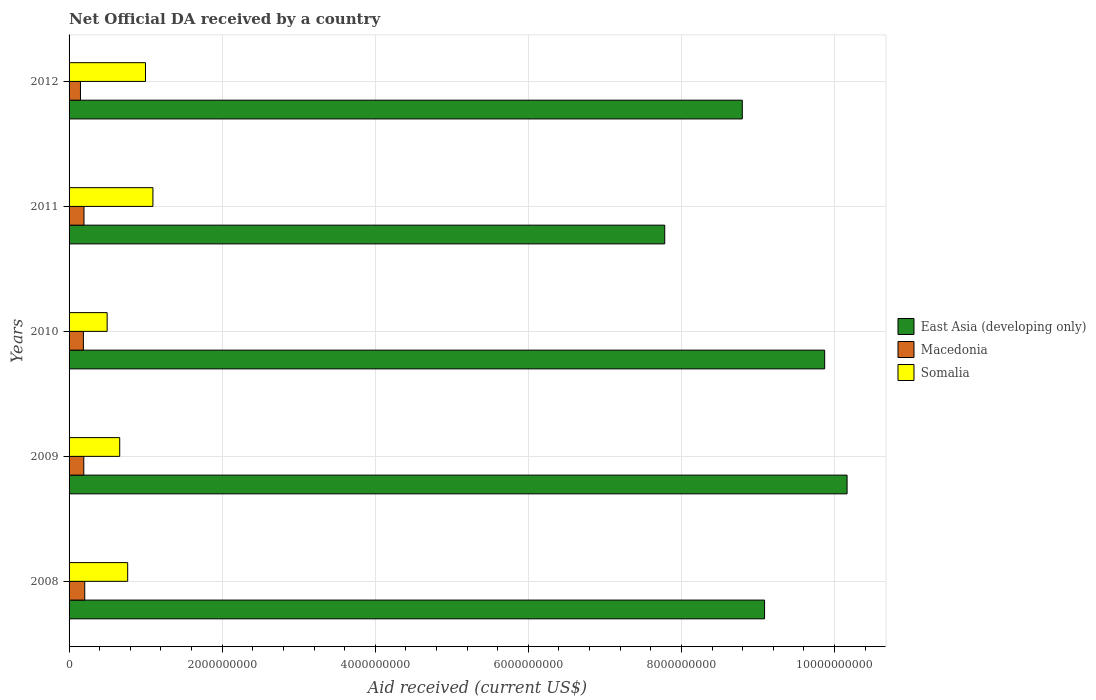How many different coloured bars are there?
Offer a very short reply. 3. Are the number of bars per tick equal to the number of legend labels?
Your answer should be very brief. Yes. How many bars are there on the 3rd tick from the bottom?
Your answer should be compact. 3. What is the label of the 2nd group of bars from the top?
Provide a succinct answer. 2011. In how many cases, is the number of bars for a given year not equal to the number of legend labels?
Provide a short and direct response. 0. What is the net official development assistance aid received in Somalia in 2011?
Your answer should be compact. 1.10e+09. Across all years, what is the maximum net official development assistance aid received in Somalia?
Provide a short and direct response. 1.10e+09. Across all years, what is the minimum net official development assistance aid received in Macedonia?
Give a very brief answer. 1.49e+08. What is the total net official development assistance aid received in Somalia in the graph?
Provide a succinct answer. 4.02e+09. What is the difference between the net official development assistance aid received in East Asia (developing only) in 2009 and that in 2010?
Your answer should be very brief. 2.93e+08. What is the difference between the net official development assistance aid received in Somalia in 2010 and the net official development assistance aid received in East Asia (developing only) in 2011?
Provide a short and direct response. -7.28e+09. What is the average net official development assistance aid received in Macedonia per year?
Make the answer very short. 1.86e+08. In the year 2009, what is the difference between the net official development assistance aid received in Macedonia and net official development assistance aid received in East Asia (developing only)?
Give a very brief answer. -9.97e+09. What is the ratio of the net official development assistance aid received in Somalia in 2008 to that in 2010?
Your answer should be compact. 1.54. Is the net official development assistance aid received in Macedonia in 2011 less than that in 2012?
Your response must be concise. No. What is the difference between the highest and the second highest net official development assistance aid received in Macedonia?
Provide a short and direct response. 9.74e+06. What is the difference between the highest and the lowest net official development assistance aid received in Somalia?
Make the answer very short. 5.98e+08. In how many years, is the net official development assistance aid received in East Asia (developing only) greater than the average net official development assistance aid received in East Asia (developing only) taken over all years?
Offer a very short reply. 2. What does the 2nd bar from the top in 2008 represents?
Offer a very short reply. Macedonia. What does the 1st bar from the bottom in 2009 represents?
Your response must be concise. East Asia (developing only). Is it the case that in every year, the sum of the net official development assistance aid received in Somalia and net official development assistance aid received in Macedonia is greater than the net official development assistance aid received in East Asia (developing only)?
Offer a very short reply. No. How many bars are there?
Keep it short and to the point. 15. Are the values on the major ticks of X-axis written in scientific E-notation?
Provide a succinct answer. No. How many legend labels are there?
Offer a terse response. 3. How are the legend labels stacked?
Keep it short and to the point. Vertical. What is the title of the graph?
Keep it short and to the point. Net Official DA received by a country. Does "Belarus" appear as one of the legend labels in the graph?
Your answer should be very brief. No. What is the label or title of the X-axis?
Keep it short and to the point. Aid received (current US$). What is the Aid received (current US$) in East Asia (developing only) in 2008?
Your answer should be compact. 9.09e+09. What is the Aid received (current US$) in Macedonia in 2008?
Offer a terse response. 2.05e+08. What is the Aid received (current US$) of Somalia in 2008?
Provide a short and direct response. 7.66e+08. What is the Aid received (current US$) of East Asia (developing only) in 2009?
Offer a terse response. 1.02e+1. What is the Aid received (current US$) of Macedonia in 2009?
Offer a very short reply. 1.92e+08. What is the Aid received (current US$) in Somalia in 2009?
Keep it short and to the point. 6.62e+08. What is the Aid received (current US$) in East Asia (developing only) in 2010?
Offer a very short reply. 9.87e+09. What is the Aid received (current US$) of Macedonia in 2010?
Keep it short and to the point. 1.87e+08. What is the Aid received (current US$) in Somalia in 2010?
Give a very brief answer. 4.98e+08. What is the Aid received (current US$) of East Asia (developing only) in 2011?
Offer a terse response. 7.78e+09. What is the Aid received (current US$) of Macedonia in 2011?
Provide a short and direct response. 1.95e+08. What is the Aid received (current US$) of Somalia in 2011?
Provide a succinct answer. 1.10e+09. What is the Aid received (current US$) of East Asia (developing only) in 2012?
Offer a terse response. 8.80e+09. What is the Aid received (current US$) of Macedonia in 2012?
Offer a very short reply. 1.49e+08. What is the Aid received (current US$) in Somalia in 2012?
Provide a short and direct response. 9.99e+08. Across all years, what is the maximum Aid received (current US$) of East Asia (developing only)?
Give a very brief answer. 1.02e+1. Across all years, what is the maximum Aid received (current US$) in Macedonia?
Ensure brevity in your answer.  2.05e+08. Across all years, what is the maximum Aid received (current US$) of Somalia?
Provide a succinct answer. 1.10e+09. Across all years, what is the minimum Aid received (current US$) of East Asia (developing only)?
Provide a short and direct response. 7.78e+09. Across all years, what is the minimum Aid received (current US$) of Macedonia?
Ensure brevity in your answer.  1.49e+08. Across all years, what is the minimum Aid received (current US$) in Somalia?
Ensure brevity in your answer.  4.98e+08. What is the total Aid received (current US$) in East Asia (developing only) in the graph?
Your response must be concise. 4.57e+1. What is the total Aid received (current US$) of Macedonia in the graph?
Give a very brief answer. 9.28e+08. What is the total Aid received (current US$) of Somalia in the graph?
Offer a very short reply. 4.02e+09. What is the difference between the Aid received (current US$) of East Asia (developing only) in 2008 and that in 2009?
Provide a succinct answer. -1.08e+09. What is the difference between the Aid received (current US$) in Macedonia in 2008 and that in 2009?
Ensure brevity in your answer.  1.22e+07. What is the difference between the Aid received (current US$) in Somalia in 2008 and that in 2009?
Provide a short and direct response. 1.04e+08. What is the difference between the Aid received (current US$) of East Asia (developing only) in 2008 and that in 2010?
Your answer should be compact. -7.85e+08. What is the difference between the Aid received (current US$) of Macedonia in 2008 and that in 2010?
Your response must be concise. 1.75e+07. What is the difference between the Aid received (current US$) in Somalia in 2008 and that in 2010?
Your response must be concise. 2.68e+08. What is the difference between the Aid received (current US$) in East Asia (developing only) in 2008 and that in 2011?
Keep it short and to the point. 1.30e+09. What is the difference between the Aid received (current US$) in Macedonia in 2008 and that in 2011?
Your response must be concise. 9.74e+06. What is the difference between the Aid received (current US$) of Somalia in 2008 and that in 2011?
Make the answer very short. -3.30e+08. What is the difference between the Aid received (current US$) of East Asia (developing only) in 2008 and that in 2012?
Keep it short and to the point. 2.91e+08. What is the difference between the Aid received (current US$) in Macedonia in 2008 and that in 2012?
Provide a short and direct response. 5.58e+07. What is the difference between the Aid received (current US$) in Somalia in 2008 and that in 2012?
Provide a short and direct response. -2.33e+08. What is the difference between the Aid received (current US$) in East Asia (developing only) in 2009 and that in 2010?
Provide a short and direct response. 2.93e+08. What is the difference between the Aid received (current US$) of Macedonia in 2009 and that in 2010?
Offer a very short reply. 5.30e+06. What is the difference between the Aid received (current US$) of Somalia in 2009 and that in 2010?
Your answer should be compact. 1.64e+08. What is the difference between the Aid received (current US$) of East Asia (developing only) in 2009 and that in 2011?
Ensure brevity in your answer.  2.38e+09. What is the difference between the Aid received (current US$) in Macedonia in 2009 and that in 2011?
Give a very brief answer. -2.50e+06. What is the difference between the Aid received (current US$) in Somalia in 2009 and that in 2011?
Your answer should be very brief. -4.34e+08. What is the difference between the Aid received (current US$) of East Asia (developing only) in 2009 and that in 2012?
Provide a succinct answer. 1.37e+09. What is the difference between the Aid received (current US$) of Macedonia in 2009 and that in 2012?
Make the answer very short. 4.35e+07. What is the difference between the Aid received (current US$) in Somalia in 2009 and that in 2012?
Ensure brevity in your answer.  -3.37e+08. What is the difference between the Aid received (current US$) in East Asia (developing only) in 2010 and that in 2011?
Offer a very short reply. 2.09e+09. What is the difference between the Aid received (current US$) of Macedonia in 2010 and that in 2011?
Provide a short and direct response. -7.80e+06. What is the difference between the Aid received (current US$) of Somalia in 2010 and that in 2011?
Offer a terse response. -5.98e+08. What is the difference between the Aid received (current US$) of East Asia (developing only) in 2010 and that in 2012?
Keep it short and to the point. 1.08e+09. What is the difference between the Aid received (current US$) in Macedonia in 2010 and that in 2012?
Your answer should be compact. 3.82e+07. What is the difference between the Aid received (current US$) in Somalia in 2010 and that in 2012?
Your answer should be very brief. -5.01e+08. What is the difference between the Aid received (current US$) in East Asia (developing only) in 2011 and that in 2012?
Your answer should be very brief. -1.01e+09. What is the difference between the Aid received (current US$) of Macedonia in 2011 and that in 2012?
Provide a succinct answer. 4.60e+07. What is the difference between the Aid received (current US$) of Somalia in 2011 and that in 2012?
Provide a short and direct response. 9.70e+07. What is the difference between the Aid received (current US$) of East Asia (developing only) in 2008 and the Aid received (current US$) of Macedonia in 2009?
Give a very brief answer. 8.89e+09. What is the difference between the Aid received (current US$) in East Asia (developing only) in 2008 and the Aid received (current US$) in Somalia in 2009?
Your response must be concise. 8.43e+09. What is the difference between the Aid received (current US$) in Macedonia in 2008 and the Aid received (current US$) in Somalia in 2009?
Give a very brief answer. -4.57e+08. What is the difference between the Aid received (current US$) in East Asia (developing only) in 2008 and the Aid received (current US$) in Macedonia in 2010?
Your answer should be compact. 8.90e+09. What is the difference between the Aid received (current US$) of East Asia (developing only) in 2008 and the Aid received (current US$) of Somalia in 2010?
Make the answer very short. 8.59e+09. What is the difference between the Aid received (current US$) in Macedonia in 2008 and the Aid received (current US$) in Somalia in 2010?
Your answer should be compact. -2.93e+08. What is the difference between the Aid received (current US$) of East Asia (developing only) in 2008 and the Aid received (current US$) of Macedonia in 2011?
Provide a short and direct response. 8.89e+09. What is the difference between the Aid received (current US$) of East Asia (developing only) in 2008 and the Aid received (current US$) of Somalia in 2011?
Offer a very short reply. 7.99e+09. What is the difference between the Aid received (current US$) of Macedonia in 2008 and the Aid received (current US$) of Somalia in 2011?
Offer a terse response. -8.91e+08. What is the difference between the Aid received (current US$) in East Asia (developing only) in 2008 and the Aid received (current US$) in Macedonia in 2012?
Offer a terse response. 8.94e+09. What is the difference between the Aid received (current US$) in East Asia (developing only) in 2008 and the Aid received (current US$) in Somalia in 2012?
Your answer should be very brief. 8.09e+09. What is the difference between the Aid received (current US$) of Macedonia in 2008 and the Aid received (current US$) of Somalia in 2012?
Keep it short and to the point. -7.94e+08. What is the difference between the Aid received (current US$) of East Asia (developing only) in 2009 and the Aid received (current US$) of Macedonia in 2010?
Offer a very short reply. 9.98e+09. What is the difference between the Aid received (current US$) in East Asia (developing only) in 2009 and the Aid received (current US$) in Somalia in 2010?
Your answer should be very brief. 9.67e+09. What is the difference between the Aid received (current US$) in Macedonia in 2009 and the Aid received (current US$) in Somalia in 2010?
Your answer should be compact. -3.05e+08. What is the difference between the Aid received (current US$) in East Asia (developing only) in 2009 and the Aid received (current US$) in Macedonia in 2011?
Provide a succinct answer. 9.97e+09. What is the difference between the Aid received (current US$) of East Asia (developing only) in 2009 and the Aid received (current US$) of Somalia in 2011?
Offer a very short reply. 9.07e+09. What is the difference between the Aid received (current US$) in Macedonia in 2009 and the Aid received (current US$) in Somalia in 2011?
Offer a very short reply. -9.03e+08. What is the difference between the Aid received (current US$) in East Asia (developing only) in 2009 and the Aid received (current US$) in Macedonia in 2012?
Your answer should be very brief. 1.00e+1. What is the difference between the Aid received (current US$) in East Asia (developing only) in 2009 and the Aid received (current US$) in Somalia in 2012?
Offer a very short reply. 9.17e+09. What is the difference between the Aid received (current US$) in Macedonia in 2009 and the Aid received (current US$) in Somalia in 2012?
Make the answer very short. -8.06e+08. What is the difference between the Aid received (current US$) of East Asia (developing only) in 2010 and the Aid received (current US$) of Macedonia in 2011?
Give a very brief answer. 9.68e+09. What is the difference between the Aid received (current US$) in East Asia (developing only) in 2010 and the Aid received (current US$) in Somalia in 2011?
Your answer should be compact. 8.78e+09. What is the difference between the Aid received (current US$) of Macedonia in 2010 and the Aid received (current US$) of Somalia in 2011?
Offer a terse response. -9.08e+08. What is the difference between the Aid received (current US$) in East Asia (developing only) in 2010 and the Aid received (current US$) in Macedonia in 2012?
Your answer should be very brief. 9.72e+09. What is the difference between the Aid received (current US$) of East Asia (developing only) in 2010 and the Aid received (current US$) of Somalia in 2012?
Offer a very short reply. 8.87e+09. What is the difference between the Aid received (current US$) of Macedonia in 2010 and the Aid received (current US$) of Somalia in 2012?
Your response must be concise. -8.11e+08. What is the difference between the Aid received (current US$) of East Asia (developing only) in 2011 and the Aid received (current US$) of Macedonia in 2012?
Make the answer very short. 7.63e+09. What is the difference between the Aid received (current US$) in East Asia (developing only) in 2011 and the Aid received (current US$) in Somalia in 2012?
Offer a very short reply. 6.78e+09. What is the difference between the Aid received (current US$) of Macedonia in 2011 and the Aid received (current US$) of Somalia in 2012?
Offer a terse response. -8.04e+08. What is the average Aid received (current US$) in East Asia (developing only) per year?
Make the answer very short. 9.14e+09. What is the average Aid received (current US$) in Macedonia per year?
Give a very brief answer. 1.86e+08. What is the average Aid received (current US$) of Somalia per year?
Offer a very short reply. 8.04e+08. In the year 2008, what is the difference between the Aid received (current US$) in East Asia (developing only) and Aid received (current US$) in Macedonia?
Offer a very short reply. 8.88e+09. In the year 2008, what is the difference between the Aid received (current US$) of East Asia (developing only) and Aid received (current US$) of Somalia?
Provide a succinct answer. 8.32e+09. In the year 2008, what is the difference between the Aid received (current US$) in Macedonia and Aid received (current US$) in Somalia?
Your response must be concise. -5.61e+08. In the year 2009, what is the difference between the Aid received (current US$) of East Asia (developing only) and Aid received (current US$) of Macedonia?
Keep it short and to the point. 9.97e+09. In the year 2009, what is the difference between the Aid received (current US$) of East Asia (developing only) and Aid received (current US$) of Somalia?
Make the answer very short. 9.50e+09. In the year 2009, what is the difference between the Aid received (current US$) in Macedonia and Aid received (current US$) in Somalia?
Ensure brevity in your answer.  -4.69e+08. In the year 2010, what is the difference between the Aid received (current US$) of East Asia (developing only) and Aid received (current US$) of Macedonia?
Offer a very short reply. 9.69e+09. In the year 2010, what is the difference between the Aid received (current US$) of East Asia (developing only) and Aid received (current US$) of Somalia?
Your answer should be compact. 9.37e+09. In the year 2010, what is the difference between the Aid received (current US$) in Macedonia and Aid received (current US$) in Somalia?
Make the answer very short. -3.10e+08. In the year 2011, what is the difference between the Aid received (current US$) in East Asia (developing only) and Aid received (current US$) in Macedonia?
Provide a short and direct response. 7.59e+09. In the year 2011, what is the difference between the Aid received (current US$) of East Asia (developing only) and Aid received (current US$) of Somalia?
Provide a succinct answer. 6.69e+09. In the year 2011, what is the difference between the Aid received (current US$) of Macedonia and Aid received (current US$) of Somalia?
Your answer should be compact. -9.01e+08. In the year 2012, what is the difference between the Aid received (current US$) of East Asia (developing only) and Aid received (current US$) of Macedonia?
Provide a short and direct response. 8.65e+09. In the year 2012, what is the difference between the Aid received (current US$) of East Asia (developing only) and Aid received (current US$) of Somalia?
Make the answer very short. 7.80e+09. In the year 2012, what is the difference between the Aid received (current US$) in Macedonia and Aid received (current US$) in Somalia?
Give a very brief answer. -8.50e+08. What is the ratio of the Aid received (current US$) in East Asia (developing only) in 2008 to that in 2009?
Your answer should be compact. 0.89. What is the ratio of the Aid received (current US$) of Macedonia in 2008 to that in 2009?
Keep it short and to the point. 1.06. What is the ratio of the Aid received (current US$) in Somalia in 2008 to that in 2009?
Your response must be concise. 1.16. What is the ratio of the Aid received (current US$) of East Asia (developing only) in 2008 to that in 2010?
Offer a terse response. 0.92. What is the ratio of the Aid received (current US$) of Macedonia in 2008 to that in 2010?
Give a very brief answer. 1.09. What is the ratio of the Aid received (current US$) in Somalia in 2008 to that in 2010?
Provide a short and direct response. 1.54. What is the ratio of the Aid received (current US$) in East Asia (developing only) in 2008 to that in 2011?
Ensure brevity in your answer.  1.17. What is the ratio of the Aid received (current US$) in Somalia in 2008 to that in 2011?
Offer a very short reply. 0.7. What is the ratio of the Aid received (current US$) of East Asia (developing only) in 2008 to that in 2012?
Your answer should be very brief. 1.03. What is the ratio of the Aid received (current US$) in Macedonia in 2008 to that in 2012?
Keep it short and to the point. 1.37. What is the ratio of the Aid received (current US$) of Somalia in 2008 to that in 2012?
Your answer should be very brief. 0.77. What is the ratio of the Aid received (current US$) in East Asia (developing only) in 2009 to that in 2010?
Ensure brevity in your answer.  1.03. What is the ratio of the Aid received (current US$) of Macedonia in 2009 to that in 2010?
Give a very brief answer. 1.03. What is the ratio of the Aid received (current US$) of Somalia in 2009 to that in 2010?
Offer a very short reply. 1.33. What is the ratio of the Aid received (current US$) of East Asia (developing only) in 2009 to that in 2011?
Ensure brevity in your answer.  1.31. What is the ratio of the Aid received (current US$) of Macedonia in 2009 to that in 2011?
Give a very brief answer. 0.99. What is the ratio of the Aid received (current US$) in Somalia in 2009 to that in 2011?
Offer a terse response. 0.6. What is the ratio of the Aid received (current US$) in East Asia (developing only) in 2009 to that in 2012?
Keep it short and to the point. 1.16. What is the ratio of the Aid received (current US$) of Macedonia in 2009 to that in 2012?
Make the answer very short. 1.29. What is the ratio of the Aid received (current US$) of Somalia in 2009 to that in 2012?
Provide a succinct answer. 0.66. What is the ratio of the Aid received (current US$) of East Asia (developing only) in 2010 to that in 2011?
Provide a short and direct response. 1.27. What is the ratio of the Aid received (current US$) in Macedonia in 2010 to that in 2011?
Offer a very short reply. 0.96. What is the ratio of the Aid received (current US$) in Somalia in 2010 to that in 2011?
Offer a terse response. 0.45. What is the ratio of the Aid received (current US$) in East Asia (developing only) in 2010 to that in 2012?
Give a very brief answer. 1.12. What is the ratio of the Aid received (current US$) of Macedonia in 2010 to that in 2012?
Your answer should be very brief. 1.26. What is the ratio of the Aid received (current US$) of Somalia in 2010 to that in 2012?
Your answer should be very brief. 0.5. What is the ratio of the Aid received (current US$) in East Asia (developing only) in 2011 to that in 2012?
Ensure brevity in your answer.  0.88. What is the ratio of the Aid received (current US$) in Macedonia in 2011 to that in 2012?
Give a very brief answer. 1.31. What is the ratio of the Aid received (current US$) in Somalia in 2011 to that in 2012?
Provide a short and direct response. 1.1. What is the difference between the highest and the second highest Aid received (current US$) in East Asia (developing only)?
Ensure brevity in your answer.  2.93e+08. What is the difference between the highest and the second highest Aid received (current US$) in Macedonia?
Ensure brevity in your answer.  9.74e+06. What is the difference between the highest and the second highest Aid received (current US$) in Somalia?
Ensure brevity in your answer.  9.70e+07. What is the difference between the highest and the lowest Aid received (current US$) in East Asia (developing only)?
Offer a terse response. 2.38e+09. What is the difference between the highest and the lowest Aid received (current US$) in Macedonia?
Give a very brief answer. 5.58e+07. What is the difference between the highest and the lowest Aid received (current US$) in Somalia?
Make the answer very short. 5.98e+08. 